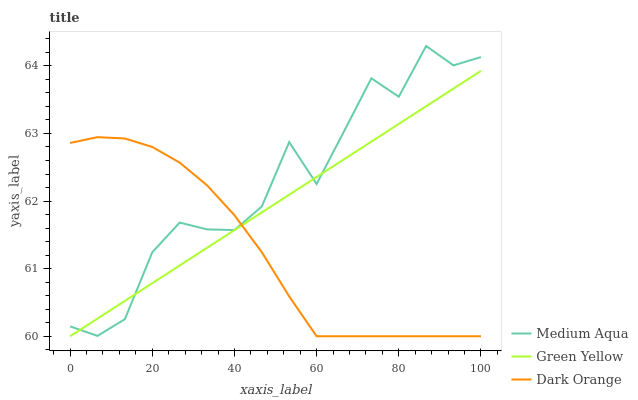Does Dark Orange have the minimum area under the curve?
Answer yes or no. Yes. Does Medium Aqua have the maximum area under the curve?
Answer yes or no. Yes. Does Green Yellow have the minimum area under the curve?
Answer yes or no. No. Does Green Yellow have the maximum area under the curve?
Answer yes or no. No. Is Green Yellow the smoothest?
Answer yes or no. Yes. Is Medium Aqua the roughest?
Answer yes or no. Yes. Is Medium Aqua the smoothest?
Answer yes or no. No. Is Green Yellow the roughest?
Answer yes or no. No. Does Medium Aqua have the lowest value?
Answer yes or no. No. Does Medium Aqua have the highest value?
Answer yes or no. Yes. Does Green Yellow have the highest value?
Answer yes or no. No. Does Green Yellow intersect Medium Aqua?
Answer yes or no. Yes. Is Green Yellow less than Medium Aqua?
Answer yes or no. No. Is Green Yellow greater than Medium Aqua?
Answer yes or no. No. 